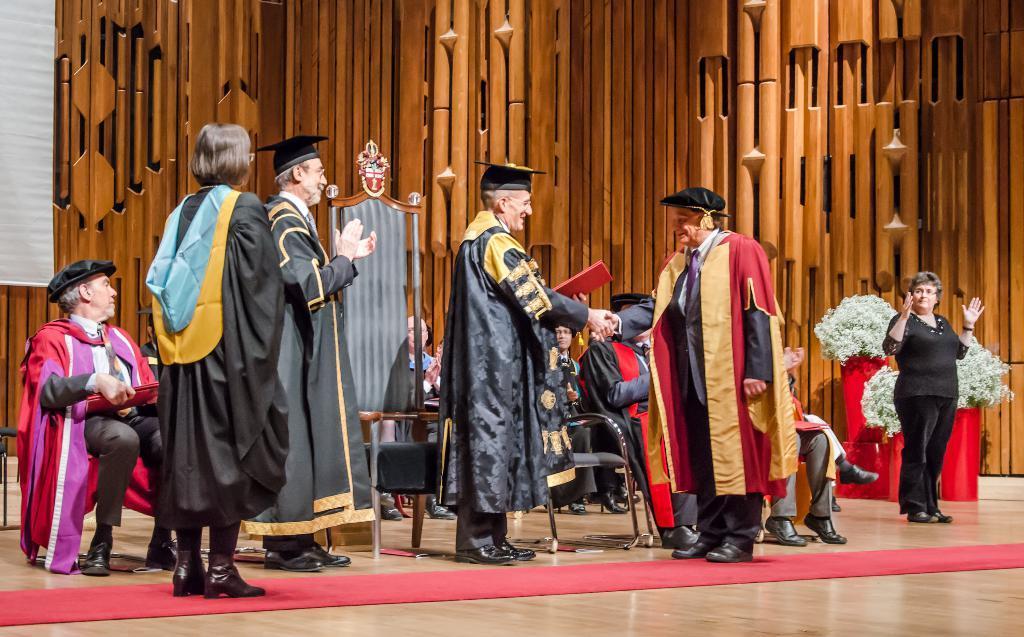In one or two sentences, can you explain what this image depicts? In this image I can see some people. On the right side, I can see the flowers. 